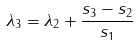<formula> <loc_0><loc_0><loc_500><loc_500>\lambda _ { 3 } = \lambda _ { 2 } + \frac { s _ { 3 } - s _ { 2 } } { s _ { 1 } } \\</formula> 